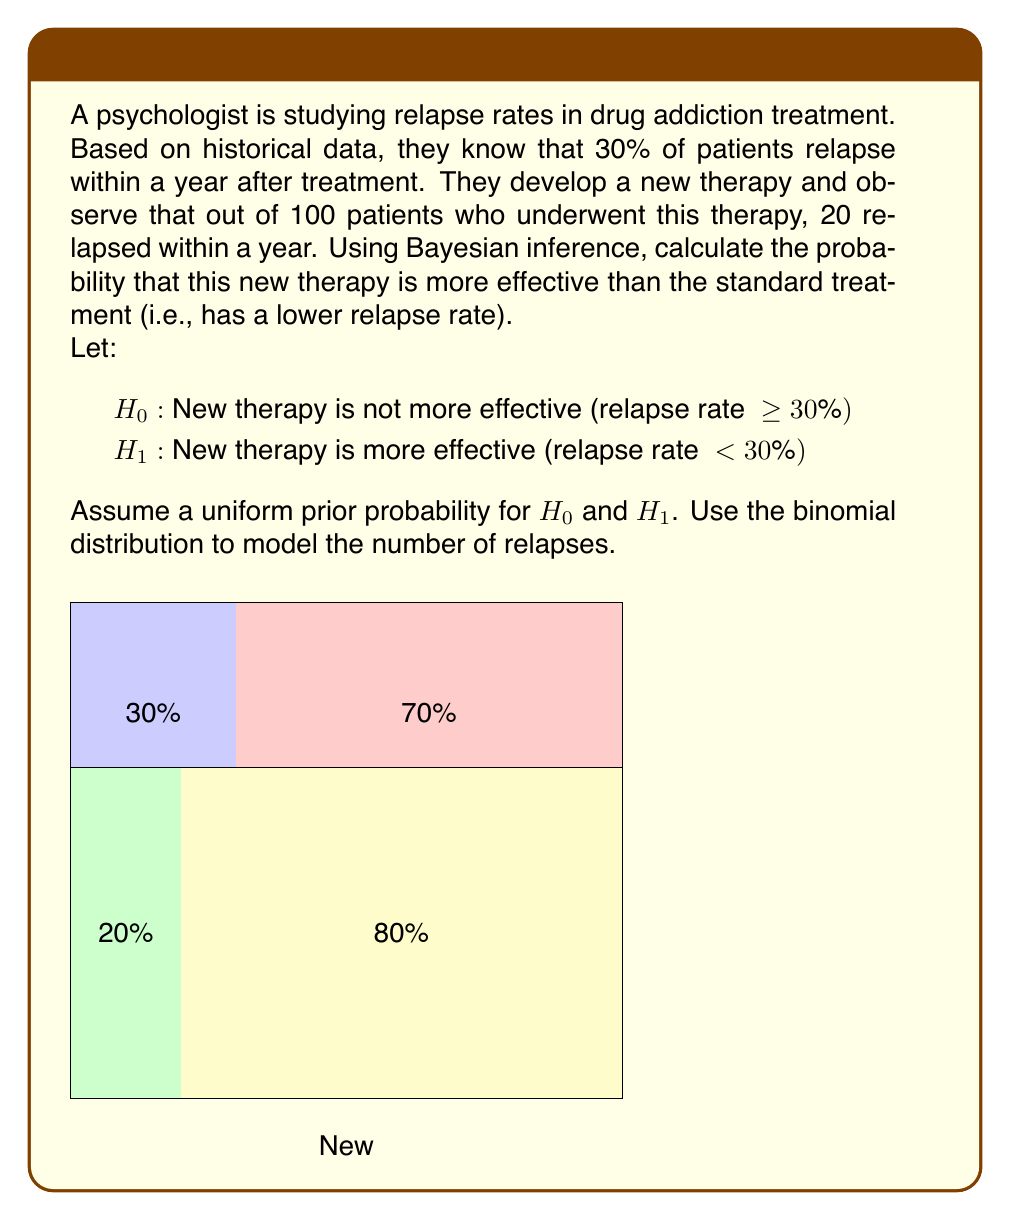Teach me how to tackle this problem. To solve this problem using Bayesian inference, we'll follow these steps:

1) First, let's define our likelihood function. We'll use the binomial distribution:

   $P(X|H) = \binom{n}{x} p^x (1-p)^{n-x}$

   where $n = 100$ (total patients), $x = 20$ (relapses), and $p$ is the probability of relapse.

2) For $H_0$, we'll use $p = 0.3$ (30% relapse rate):
   
   $P(X|H_0) = \binom{100}{20} 0.3^{20} (1-0.3)^{80} \approx 0.0399$

3) For $H_1$, we need to integrate over all possible values of $p$ from 0 to 0.3:

   $P(X|H_1) = \int_0^{0.3} \binom{100}{20} p^{20} (1-p)^{80} dp \approx 0.0892$

4) Assuming a uniform prior, $P(H_0) = P(H_1) = 0.5$

5) Now we can apply Bayes' theorem:

   $P(H_1|X) = \frac{P(X|H_1)P(H_1)}{P(X|H_1)P(H_1) + P(X|H_0)P(H_0)}$

6) Substituting the values:

   $P(H_1|X) = \frac{0.0892 * 0.5}{0.0892 * 0.5 + 0.0399 * 0.5} \approx 0.6910$

Therefore, the probability that the new therapy is more effective is approximately 0.6910 or 69.10%.
Answer: $0.6910$ or $69.10\%$ 